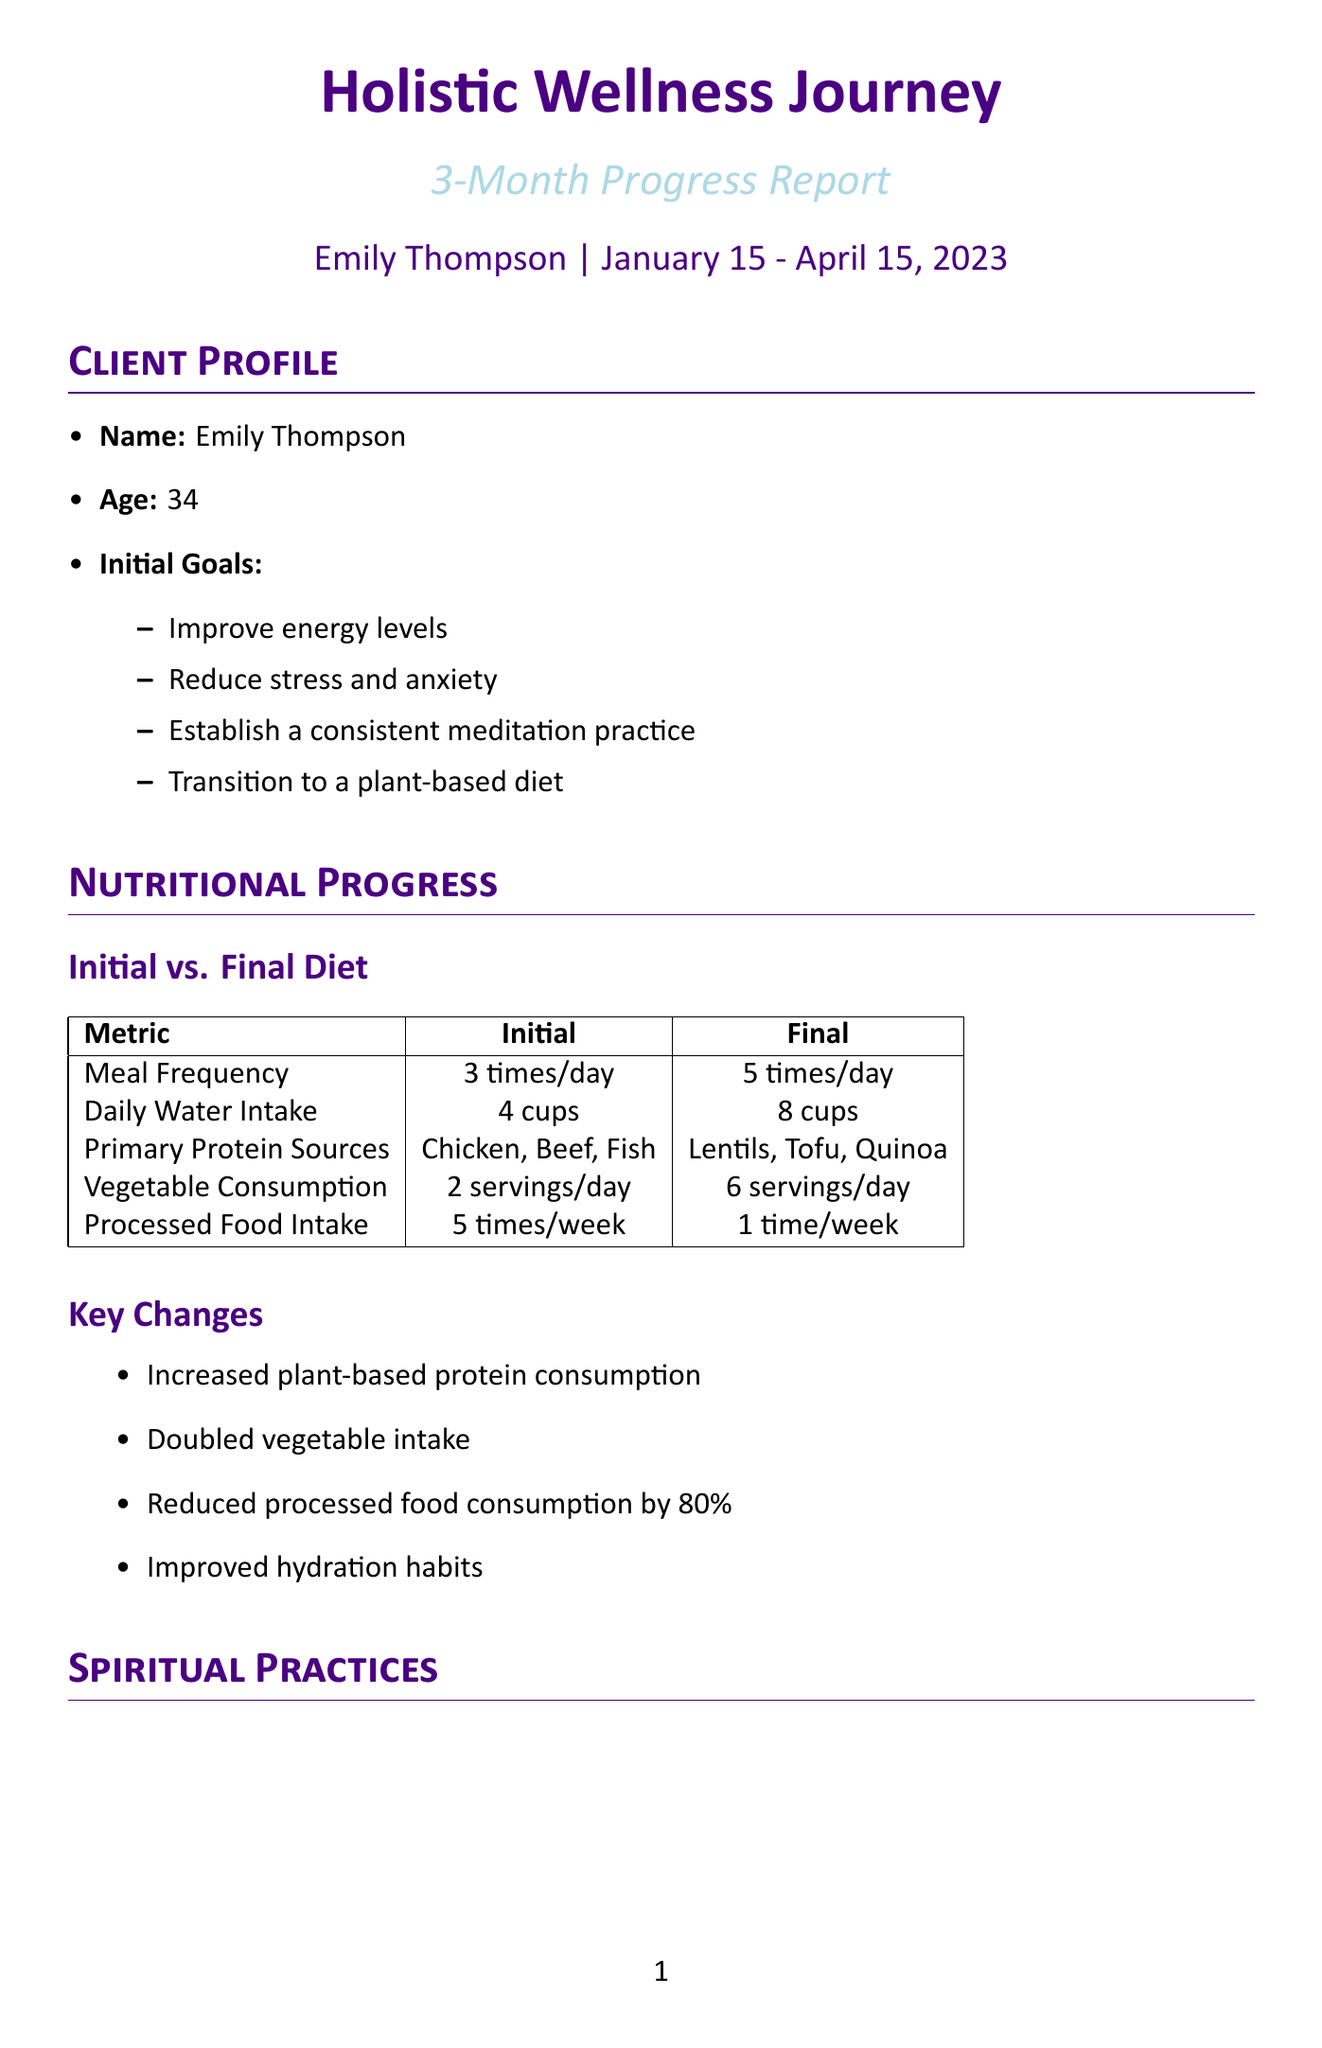What were Emily's initial goals? The initial goals include improving energy levels, reducing stress and anxiety, establishing a consistent meditation practice, and transitioning to a plant-based diet.
Answer: Improve energy levels, Reduce stress and anxiety, Establish a consistent meditation practice, Transition to a plant-based diet How many servings of vegetables did Emily consume daily at the end of the period? At the end of the 3-month period, Emily increased her vegetable consumption to 6 servings per day.
Answer: 6 servings What was Emily's initial score on the WEMWBS? The initial score on the Warwick-Edinburgh Mental Well-being Scale was 38.
Answer: 38 How frequently did Emily practice yoga at the end of the period? By the end of the 3-month period, Emily practiced yoga 3 times per week.
Answer: 3 times per week What impact did the changes in nutritional habits have on processed food intake? Emily reduced her processed food consumption by 80% from 5 times per week to 1 time per week.
Answer: Reduced processed food consumption by 80% What was Emily's final score on the WEMWBS? The final score on the Warwick-Edinburgh Mental Well-being Scale was 52.
Answer: 52 Which practice did Emily incorporate for mind-body connection? Emily incorporated yoga for mind-body connection as part of her spiritual practices.
Answer: Yoga What strategies improved Emily's stress management from poor to good? Key strategies included deep breathing exercises, nature walks, and mindful technology use.
Answer: Deep breathing exercises, Nature walks, Mindful technology use What area of her health did Emily achieve a success rate of 85%? Emily achieved an 85% success rate in her overall progress during her holistic wellness journey.
Answer: 85% 